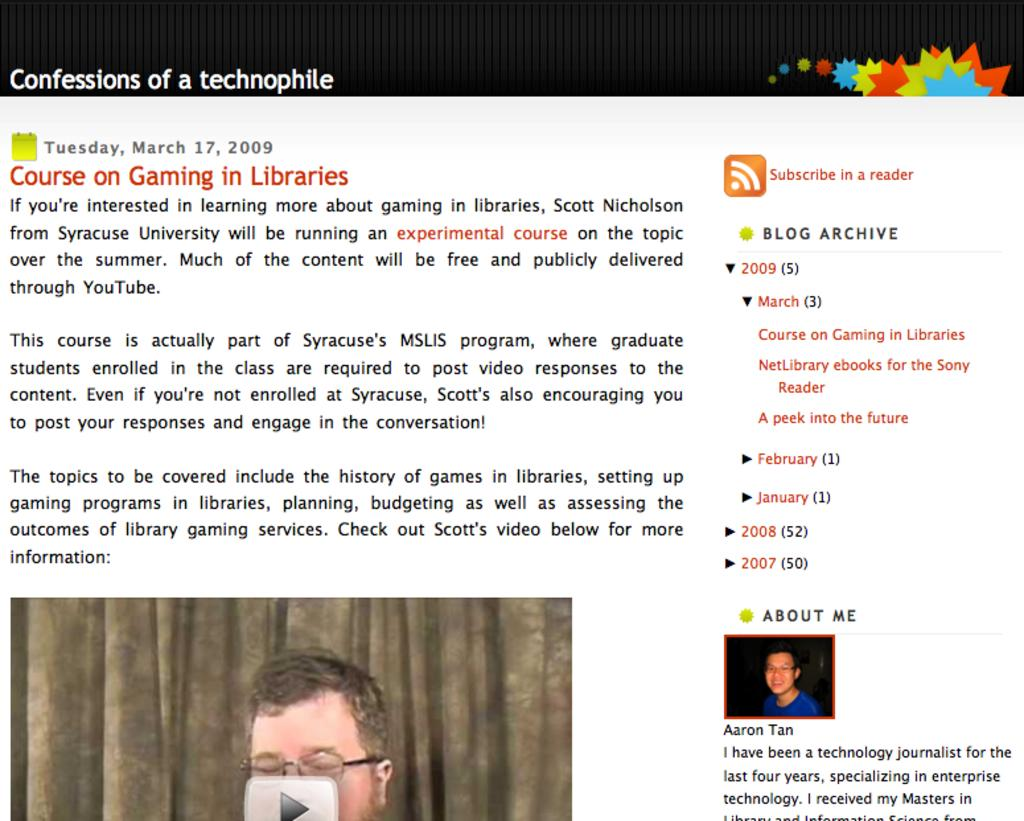What is the main object in the image? There is a paper in the image. What is depicted on the paper? A person's face is depicted on the paper. Are there any words or text on the paper? Yes, there is writing on the paper. How many branches can be seen growing from the person's face on the paper? There are no branches depicted on the person's face in the image. 